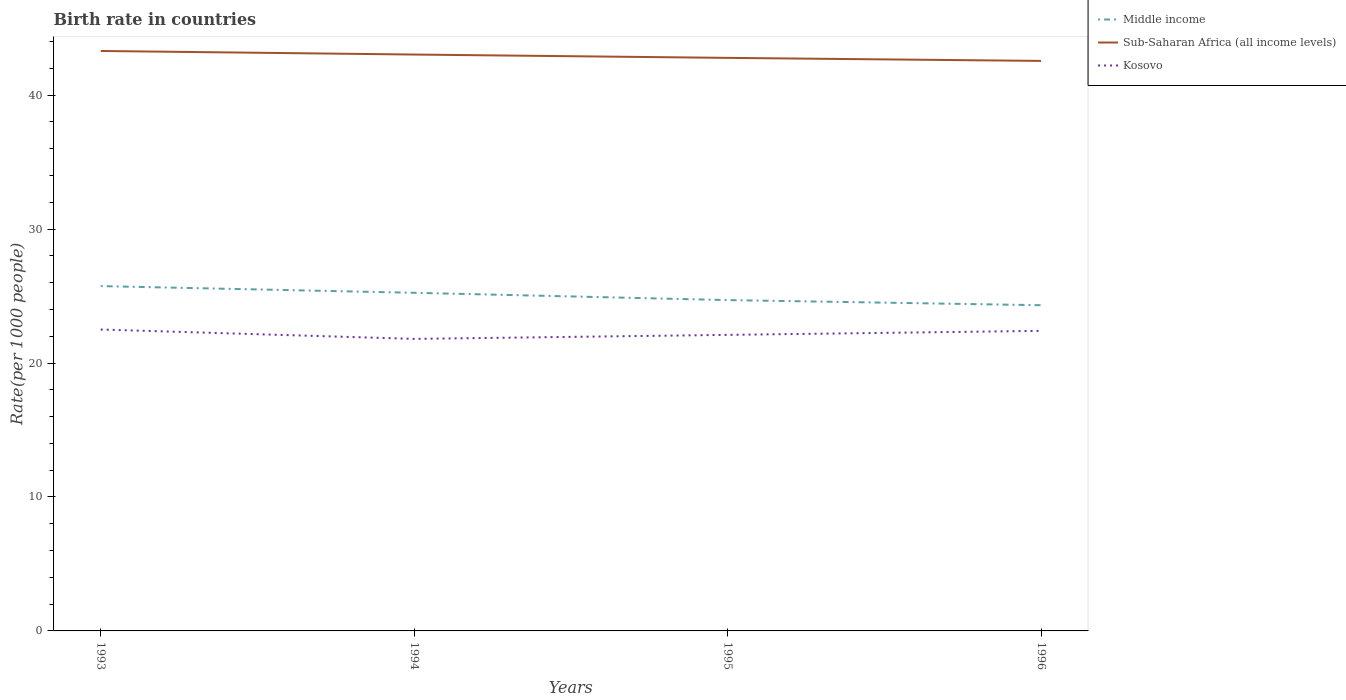How many different coloured lines are there?
Your answer should be compact. 3. Does the line corresponding to Kosovo intersect with the line corresponding to Sub-Saharan Africa (all income levels)?
Keep it short and to the point. No. Across all years, what is the maximum birth rate in Kosovo?
Give a very brief answer. 21.8. What is the total birth rate in Kosovo in the graph?
Make the answer very short. -0.6. What is the difference between the highest and the second highest birth rate in Kosovo?
Keep it short and to the point. 0.7. How many lines are there?
Your response must be concise. 3. Are the values on the major ticks of Y-axis written in scientific E-notation?
Ensure brevity in your answer.  No. Where does the legend appear in the graph?
Offer a terse response. Top right. What is the title of the graph?
Provide a short and direct response. Birth rate in countries. What is the label or title of the X-axis?
Your response must be concise. Years. What is the label or title of the Y-axis?
Your response must be concise. Rate(per 1000 people). What is the Rate(per 1000 people) in Middle income in 1993?
Your answer should be compact. 25.74. What is the Rate(per 1000 people) of Sub-Saharan Africa (all income levels) in 1993?
Give a very brief answer. 43.29. What is the Rate(per 1000 people) in Kosovo in 1993?
Ensure brevity in your answer.  22.5. What is the Rate(per 1000 people) in Middle income in 1994?
Offer a very short reply. 25.24. What is the Rate(per 1000 people) of Sub-Saharan Africa (all income levels) in 1994?
Your answer should be very brief. 43.03. What is the Rate(per 1000 people) of Kosovo in 1994?
Provide a short and direct response. 21.8. What is the Rate(per 1000 people) of Middle income in 1995?
Make the answer very short. 24.7. What is the Rate(per 1000 people) in Sub-Saharan Africa (all income levels) in 1995?
Give a very brief answer. 42.78. What is the Rate(per 1000 people) in Kosovo in 1995?
Your answer should be compact. 22.1. What is the Rate(per 1000 people) in Middle income in 1996?
Your response must be concise. 24.31. What is the Rate(per 1000 people) of Sub-Saharan Africa (all income levels) in 1996?
Give a very brief answer. 42.55. What is the Rate(per 1000 people) of Kosovo in 1996?
Offer a terse response. 22.4. Across all years, what is the maximum Rate(per 1000 people) of Middle income?
Offer a very short reply. 25.74. Across all years, what is the maximum Rate(per 1000 people) of Sub-Saharan Africa (all income levels)?
Keep it short and to the point. 43.29. Across all years, what is the maximum Rate(per 1000 people) in Kosovo?
Provide a short and direct response. 22.5. Across all years, what is the minimum Rate(per 1000 people) of Middle income?
Your answer should be very brief. 24.31. Across all years, what is the minimum Rate(per 1000 people) of Sub-Saharan Africa (all income levels)?
Provide a succinct answer. 42.55. Across all years, what is the minimum Rate(per 1000 people) in Kosovo?
Your response must be concise. 21.8. What is the total Rate(per 1000 people) in Middle income in the graph?
Make the answer very short. 99.99. What is the total Rate(per 1000 people) of Sub-Saharan Africa (all income levels) in the graph?
Your response must be concise. 171.65. What is the total Rate(per 1000 people) of Kosovo in the graph?
Offer a very short reply. 88.8. What is the difference between the Rate(per 1000 people) of Middle income in 1993 and that in 1994?
Provide a succinct answer. 0.5. What is the difference between the Rate(per 1000 people) in Sub-Saharan Africa (all income levels) in 1993 and that in 1994?
Your response must be concise. 0.27. What is the difference between the Rate(per 1000 people) of Kosovo in 1993 and that in 1994?
Provide a succinct answer. 0.7. What is the difference between the Rate(per 1000 people) of Middle income in 1993 and that in 1995?
Keep it short and to the point. 1.04. What is the difference between the Rate(per 1000 people) of Sub-Saharan Africa (all income levels) in 1993 and that in 1995?
Your answer should be very brief. 0.51. What is the difference between the Rate(per 1000 people) of Kosovo in 1993 and that in 1995?
Provide a succinct answer. 0.4. What is the difference between the Rate(per 1000 people) of Middle income in 1993 and that in 1996?
Provide a short and direct response. 1.43. What is the difference between the Rate(per 1000 people) in Sub-Saharan Africa (all income levels) in 1993 and that in 1996?
Provide a short and direct response. 0.74. What is the difference between the Rate(per 1000 people) in Kosovo in 1993 and that in 1996?
Give a very brief answer. 0.1. What is the difference between the Rate(per 1000 people) of Middle income in 1994 and that in 1995?
Make the answer very short. 0.55. What is the difference between the Rate(per 1000 people) in Sub-Saharan Africa (all income levels) in 1994 and that in 1995?
Offer a very short reply. 0.25. What is the difference between the Rate(per 1000 people) of Middle income in 1994 and that in 1996?
Your answer should be very brief. 0.93. What is the difference between the Rate(per 1000 people) of Sub-Saharan Africa (all income levels) in 1994 and that in 1996?
Your answer should be compact. 0.47. What is the difference between the Rate(per 1000 people) of Kosovo in 1994 and that in 1996?
Provide a succinct answer. -0.6. What is the difference between the Rate(per 1000 people) of Middle income in 1995 and that in 1996?
Offer a very short reply. 0.38. What is the difference between the Rate(per 1000 people) in Sub-Saharan Africa (all income levels) in 1995 and that in 1996?
Offer a terse response. 0.23. What is the difference between the Rate(per 1000 people) in Kosovo in 1995 and that in 1996?
Provide a succinct answer. -0.3. What is the difference between the Rate(per 1000 people) in Middle income in 1993 and the Rate(per 1000 people) in Sub-Saharan Africa (all income levels) in 1994?
Provide a succinct answer. -17.29. What is the difference between the Rate(per 1000 people) in Middle income in 1993 and the Rate(per 1000 people) in Kosovo in 1994?
Offer a terse response. 3.94. What is the difference between the Rate(per 1000 people) in Sub-Saharan Africa (all income levels) in 1993 and the Rate(per 1000 people) in Kosovo in 1994?
Make the answer very short. 21.49. What is the difference between the Rate(per 1000 people) in Middle income in 1993 and the Rate(per 1000 people) in Sub-Saharan Africa (all income levels) in 1995?
Ensure brevity in your answer.  -17.04. What is the difference between the Rate(per 1000 people) in Middle income in 1993 and the Rate(per 1000 people) in Kosovo in 1995?
Make the answer very short. 3.64. What is the difference between the Rate(per 1000 people) in Sub-Saharan Africa (all income levels) in 1993 and the Rate(per 1000 people) in Kosovo in 1995?
Ensure brevity in your answer.  21.19. What is the difference between the Rate(per 1000 people) in Middle income in 1993 and the Rate(per 1000 people) in Sub-Saharan Africa (all income levels) in 1996?
Your answer should be compact. -16.81. What is the difference between the Rate(per 1000 people) in Middle income in 1993 and the Rate(per 1000 people) in Kosovo in 1996?
Give a very brief answer. 3.34. What is the difference between the Rate(per 1000 people) in Sub-Saharan Africa (all income levels) in 1993 and the Rate(per 1000 people) in Kosovo in 1996?
Keep it short and to the point. 20.89. What is the difference between the Rate(per 1000 people) of Middle income in 1994 and the Rate(per 1000 people) of Sub-Saharan Africa (all income levels) in 1995?
Offer a terse response. -17.54. What is the difference between the Rate(per 1000 people) in Middle income in 1994 and the Rate(per 1000 people) in Kosovo in 1995?
Keep it short and to the point. 3.14. What is the difference between the Rate(per 1000 people) in Sub-Saharan Africa (all income levels) in 1994 and the Rate(per 1000 people) in Kosovo in 1995?
Your answer should be very brief. 20.93. What is the difference between the Rate(per 1000 people) in Middle income in 1994 and the Rate(per 1000 people) in Sub-Saharan Africa (all income levels) in 1996?
Offer a terse response. -17.31. What is the difference between the Rate(per 1000 people) of Middle income in 1994 and the Rate(per 1000 people) of Kosovo in 1996?
Provide a succinct answer. 2.84. What is the difference between the Rate(per 1000 people) in Sub-Saharan Africa (all income levels) in 1994 and the Rate(per 1000 people) in Kosovo in 1996?
Give a very brief answer. 20.63. What is the difference between the Rate(per 1000 people) of Middle income in 1995 and the Rate(per 1000 people) of Sub-Saharan Africa (all income levels) in 1996?
Offer a terse response. -17.85. What is the difference between the Rate(per 1000 people) of Middle income in 1995 and the Rate(per 1000 people) of Kosovo in 1996?
Keep it short and to the point. 2.3. What is the difference between the Rate(per 1000 people) in Sub-Saharan Africa (all income levels) in 1995 and the Rate(per 1000 people) in Kosovo in 1996?
Give a very brief answer. 20.38. What is the average Rate(per 1000 people) in Middle income per year?
Your response must be concise. 25. What is the average Rate(per 1000 people) in Sub-Saharan Africa (all income levels) per year?
Provide a short and direct response. 42.91. What is the average Rate(per 1000 people) of Kosovo per year?
Your answer should be very brief. 22.2. In the year 1993, what is the difference between the Rate(per 1000 people) of Middle income and Rate(per 1000 people) of Sub-Saharan Africa (all income levels)?
Give a very brief answer. -17.55. In the year 1993, what is the difference between the Rate(per 1000 people) in Middle income and Rate(per 1000 people) in Kosovo?
Make the answer very short. 3.24. In the year 1993, what is the difference between the Rate(per 1000 people) of Sub-Saharan Africa (all income levels) and Rate(per 1000 people) of Kosovo?
Offer a terse response. 20.79. In the year 1994, what is the difference between the Rate(per 1000 people) of Middle income and Rate(per 1000 people) of Sub-Saharan Africa (all income levels)?
Provide a succinct answer. -17.78. In the year 1994, what is the difference between the Rate(per 1000 people) in Middle income and Rate(per 1000 people) in Kosovo?
Give a very brief answer. 3.44. In the year 1994, what is the difference between the Rate(per 1000 people) in Sub-Saharan Africa (all income levels) and Rate(per 1000 people) in Kosovo?
Ensure brevity in your answer.  21.23. In the year 1995, what is the difference between the Rate(per 1000 people) in Middle income and Rate(per 1000 people) in Sub-Saharan Africa (all income levels)?
Provide a succinct answer. -18.08. In the year 1995, what is the difference between the Rate(per 1000 people) in Middle income and Rate(per 1000 people) in Kosovo?
Your answer should be very brief. 2.6. In the year 1995, what is the difference between the Rate(per 1000 people) in Sub-Saharan Africa (all income levels) and Rate(per 1000 people) in Kosovo?
Provide a succinct answer. 20.68. In the year 1996, what is the difference between the Rate(per 1000 people) of Middle income and Rate(per 1000 people) of Sub-Saharan Africa (all income levels)?
Give a very brief answer. -18.24. In the year 1996, what is the difference between the Rate(per 1000 people) in Middle income and Rate(per 1000 people) in Kosovo?
Make the answer very short. 1.91. In the year 1996, what is the difference between the Rate(per 1000 people) in Sub-Saharan Africa (all income levels) and Rate(per 1000 people) in Kosovo?
Your response must be concise. 20.15. What is the ratio of the Rate(per 1000 people) in Middle income in 1993 to that in 1994?
Your response must be concise. 1.02. What is the ratio of the Rate(per 1000 people) in Sub-Saharan Africa (all income levels) in 1993 to that in 1994?
Make the answer very short. 1.01. What is the ratio of the Rate(per 1000 people) in Kosovo in 1993 to that in 1994?
Offer a terse response. 1.03. What is the ratio of the Rate(per 1000 people) in Middle income in 1993 to that in 1995?
Offer a terse response. 1.04. What is the ratio of the Rate(per 1000 people) in Kosovo in 1993 to that in 1995?
Provide a short and direct response. 1.02. What is the ratio of the Rate(per 1000 people) in Middle income in 1993 to that in 1996?
Your response must be concise. 1.06. What is the ratio of the Rate(per 1000 people) in Sub-Saharan Africa (all income levels) in 1993 to that in 1996?
Make the answer very short. 1.02. What is the ratio of the Rate(per 1000 people) in Kosovo in 1993 to that in 1996?
Provide a short and direct response. 1. What is the ratio of the Rate(per 1000 people) in Middle income in 1994 to that in 1995?
Keep it short and to the point. 1.02. What is the ratio of the Rate(per 1000 people) in Kosovo in 1994 to that in 1995?
Make the answer very short. 0.99. What is the ratio of the Rate(per 1000 people) of Middle income in 1994 to that in 1996?
Provide a succinct answer. 1.04. What is the ratio of the Rate(per 1000 people) of Sub-Saharan Africa (all income levels) in 1994 to that in 1996?
Your answer should be very brief. 1.01. What is the ratio of the Rate(per 1000 people) of Kosovo in 1994 to that in 1996?
Ensure brevity in your answer.  0.97. What is the ratio of the Rate(per 1000 people) of Middle income in 1995 to that in 1996?
Provide a short and direct response. 1.02. What is the ratio of the Rate(per 1000 people) in Kosovo in 1995 to that in 1996?
Provide a short and direct response. 0.99. What is the difference between the highest and the second highest Rate(per 1000 people) of Middle income?
Provide a succinct answer. 0.5. What is the difference between the highest and the second highest Rate(per 1000 people) of Sub-Saharan Africa (all income levels)?
Your response must be concise. 0.27. What is the difference between the highest and the second highest Rate(per 1000 people) in Kosovo?
Offer a very short reply. 0.1. What is the difference between the highest and the lowest Rate(per 1000 people) of Middle income?
Your response must be concise. 1.43. What is the difference between the highest and the lowest Rate(per 1000 people) in Sub-Saharan Africa (all income levels)?
Your answer should be very brief. 0.74. What is the difference between the highest and the lowest Rate(per 1000 people) in Kosovo?
Your answer should be very brief. 0.7. 